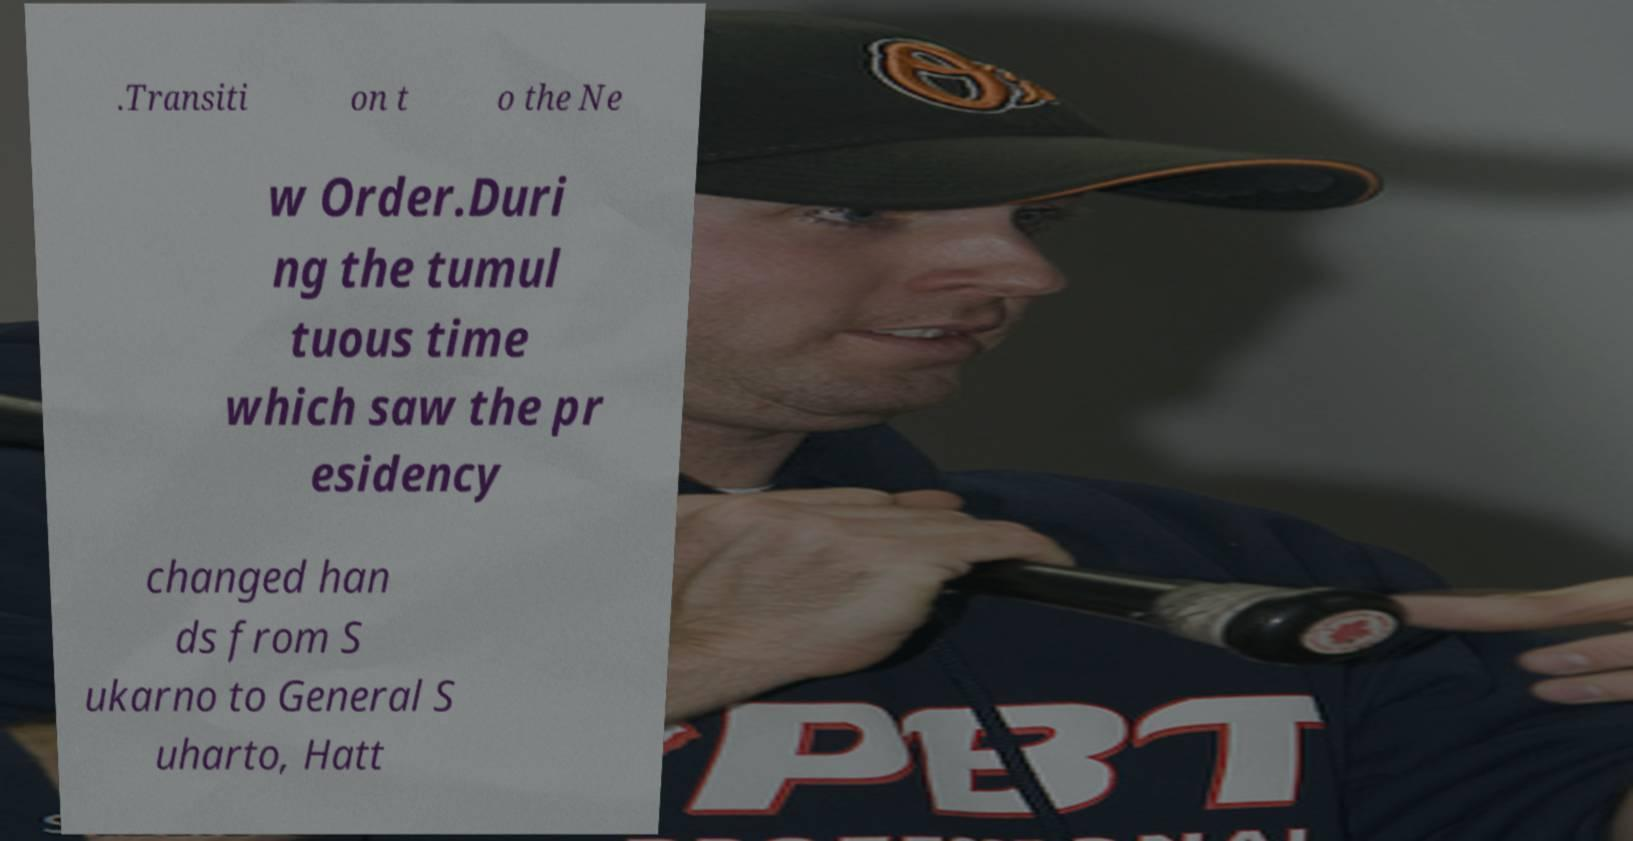What messages or text are displayed in this image? I need them in a readable, typed format. .Transiti on t o the Ne w Order.Duri ng the tumul tuous time which saw the pr esidency changed han ds from S ukarno to General S uharto, Hatt 